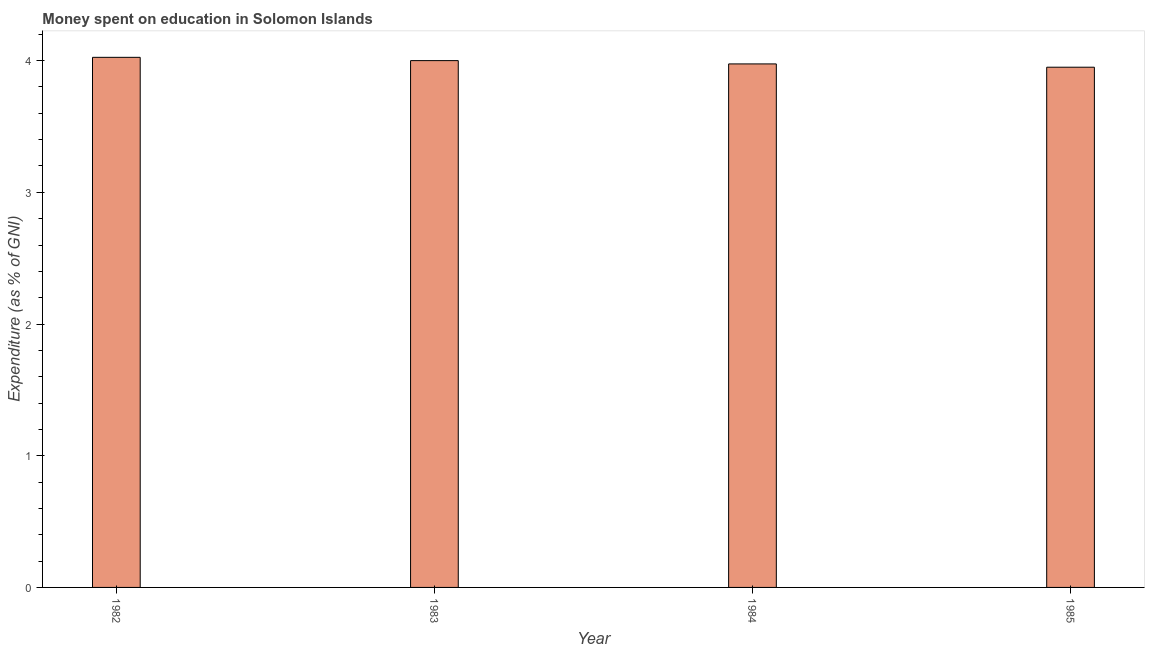What is the title of the graph?
Keep it short and to the point. Money spent on education in Solomon Islands. What is the label or title of the Y-axis?
Provide a succinct answer. Expenditure (as % of GNI). What is the expenditure on education in 1984?
Make the answer very short. 3.98. Across all years, what is the maximum expenditure on education?
Your response must be concise. 4.03. Across all years, what is the minimum expenditure on education?
Your answer should be compact. 3.95. In which year was the expenditure on education maximum?
Offer a very short reply. 1982. What is the sum of the expenditure on education?
Your answer should be compact. 15.95. What is the difference between the expenditure on education in 1982 and 1985?
Give a very brief answer. 0.07. What is the average expenditure on education per year?
Your answer should be very brief. 3.99. What is the median expenditure on education?
Provide a succinct answer. 3.99. What is the ratio of the expenditure on education in 1984 to that in 1985?
Your response must be concise. 1.01. Is the expenditure on education in 1982 less than that in 1983?
Make the answer very short. No. Is the difference between the expenditure on education in 1983 and 1985 greater than the difference between any two years?
Offer a terse response. No. What is the difference between the highest and the second highest expenditure on education?
Give a very brief answer. 0.03. Is the sum of the expenditure on education in 1983 and 1984 greater than the maximum expenditure on education across all years?
Give a very brief answer. Yes. In how many years, is the expenditure on education greater than the average expenditure on education taken over all years?
Provide a succinct answer. 2. Are all the bars in the graph horizontal?
Provide a succinct answer. No. What is the Expenditure (as % of GNI) in 1982?
Give a very brief answer. 4.03. What is the Expenditure (as % of GNI) in 1983?
Your answer should be compact. 4. What is the Expenditure (as % of GNI) in 1984?
Make the answer very short. 3.98. What is the Expenditure (as % of GNI) in 1985?
Give a very brief answer. 3.95. What is the difference between the Expenditure (as % of GNI) in 1982 and 1983?
Your answer should be very brief. 0.03. What is the difference between the Expenditure (as % of GNI) in 1982 and 1984?
Make the answer very short. 0.05. What is the difference between the Expenditure (as % of GNI) in 1982 and 1985?
Give a very brief answer. 0.07. What is the difference between the Expenditure (as % of GNI) in 1983 and 1984?
Make the answer very short. 0.03. What is the difference between the Expenditure (as % of GNI) in 1983 and 1985?
Your response must be concise. 0.05. What is the difference between the Expenditure (as % of GNI) in 1984 and 1985?
Make the answer very short. 0.03. What is the ratio of the Expenditure (as % of GNI) in 1982 to that in 1985?
Your answer should be very brief. 1.02. What is the ratio of the Expenditure (as % of GNI) in 1983 to that in 1984?
Provide a short and direct response. 1.01. What is the ratio of the Expenditure (as % of GNI) in 1983 to that in 1985?
Keep it short and to the point. 1.01. 